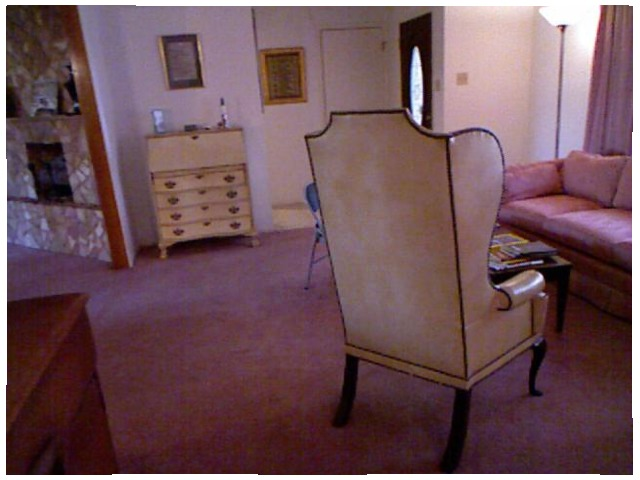<image>
Is there a chair next to the frame? No. The chair is not positioned next to the frame. They are located in different areas of the scene. 